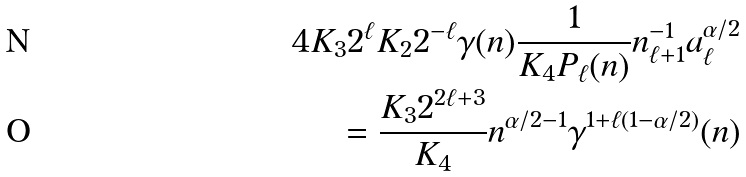Convert formula to latex. <formula><loc_0><loc_0><loc_500><loc_500>4 K _ { 3 } 2 ^ { \ell } K _ { 2 } 2 ^ { - \ell } \gamma ( n ) \frac { 1 } { K _ { 4 } P _ { \ell } ( n ) } n _ { \ell + 1 } ^ { - 1 } a _ { \ell } ^ { \alpha / 2 } \\ = \frac { K _ { 3 } 2 ^ { 2 \ell + 3 } } { K _ { 4 } } n ^ { \alpha / 2 - 1 } \gamma ^ { 1 + \ell ( 1 - \alpha / 2 ) } ( n )</formula> 